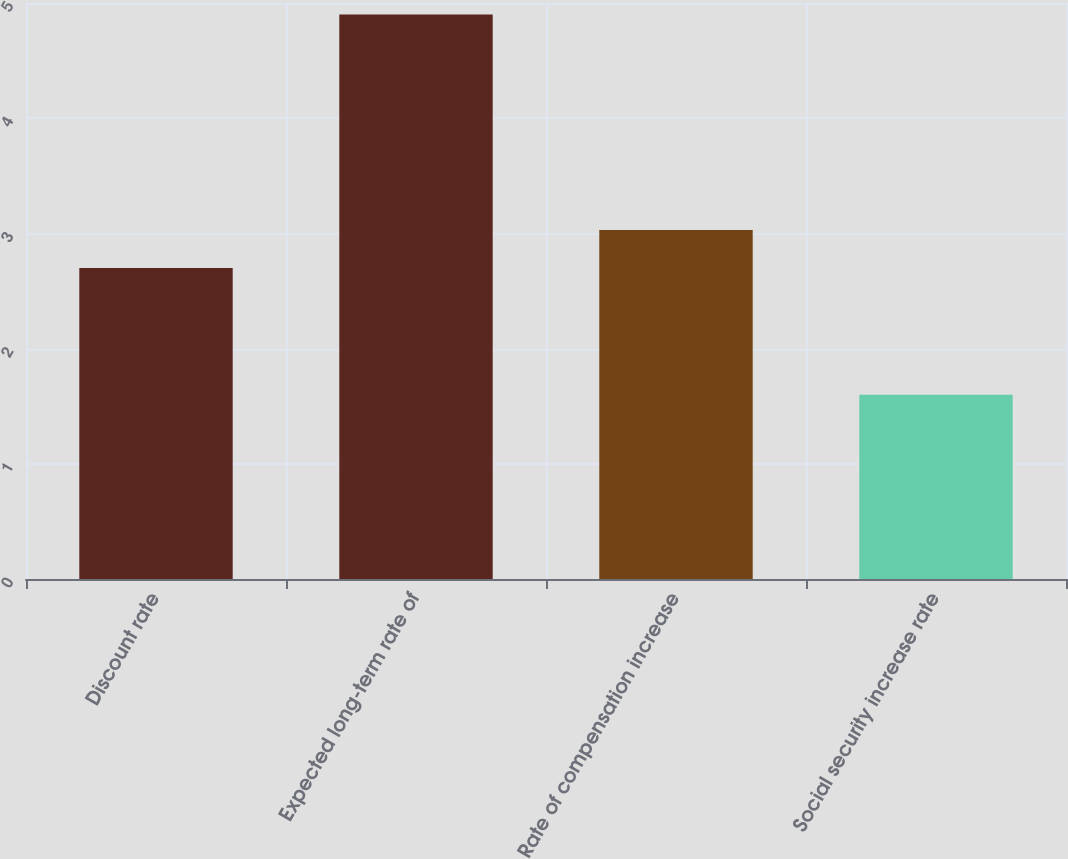Convert chart. <chart><loc_0><loc_0><loc_500><loc_500><bar_chart><fcel>Discount rate<fcel>Expected long-term rate of<fcel>Rate of compensation increase<fcel>Social security increase rate<nl><fcel>2.7<fcel>4.9<fcel>3.03<fcel>1.6<nl></chart> 